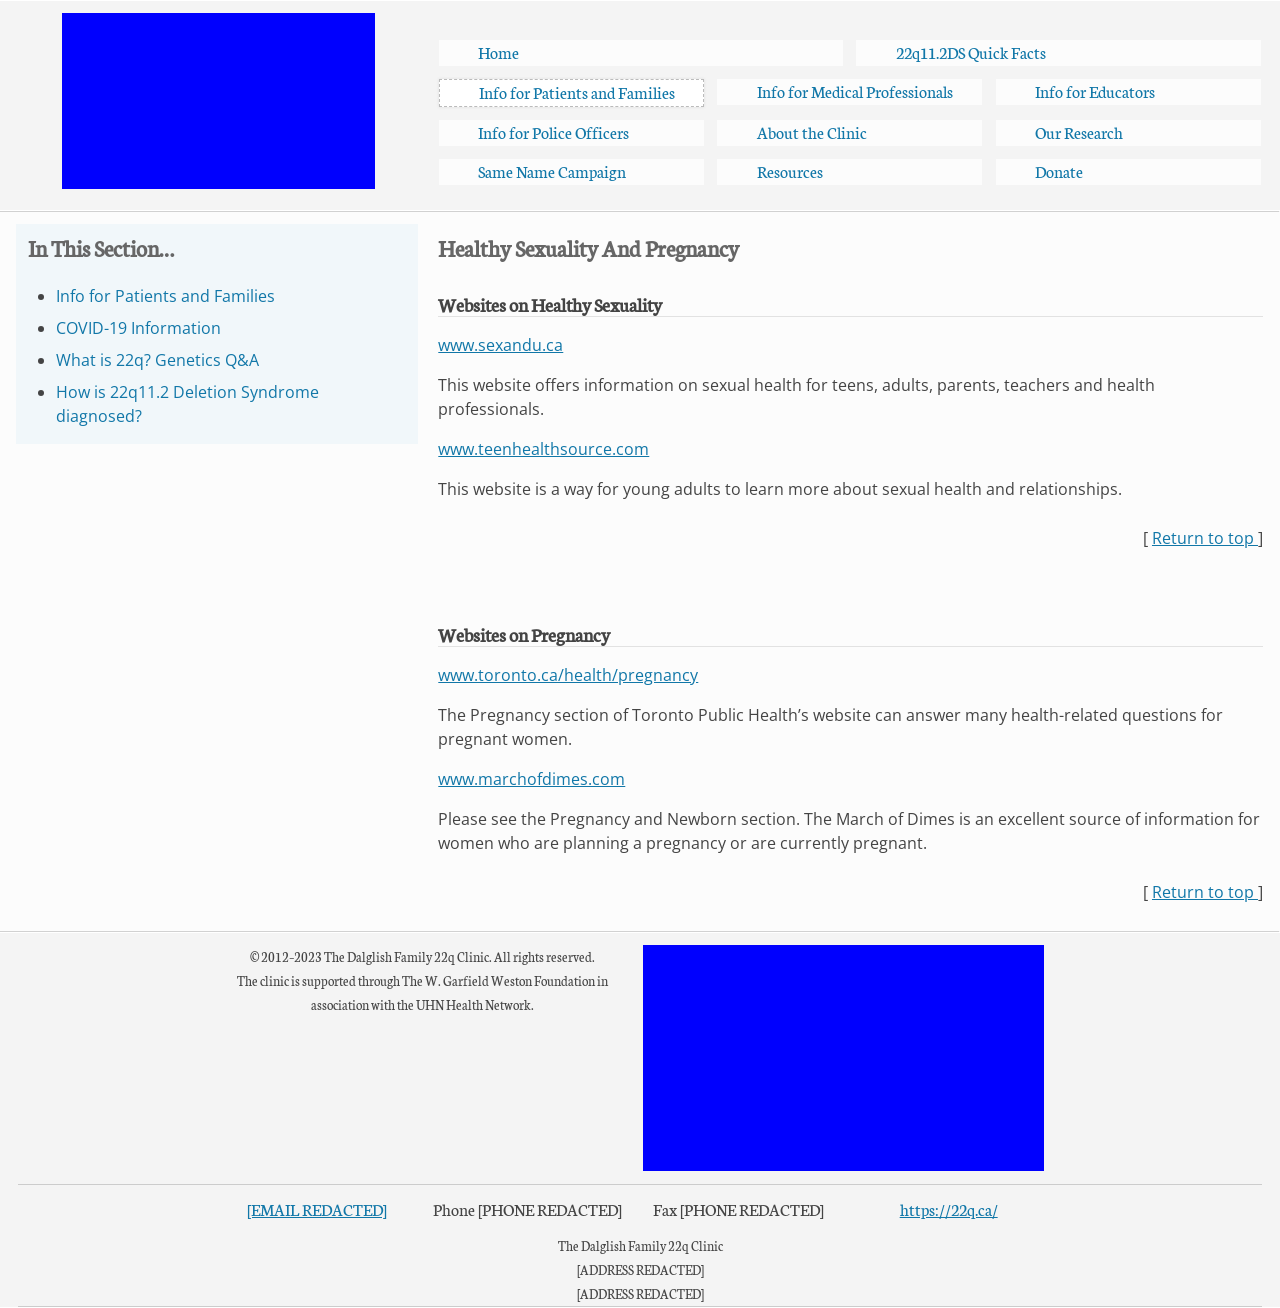What tools or technologies besides HTML are used or needed to manage and maintain a website like the one displayed? Alongside HTML for structuring the website, CSS is employed for styling, and JavaScript for interactive elements. For content management, systems such as WordPress or Drupal could be utilized. Hosting services and domain registration are also necessary. For user interaction, databases and backend services might be incorporated using server-side languages like PHP or frameworks such as Node.js. On the front end, frameworks like React or Angular could enhance user interfaces. 